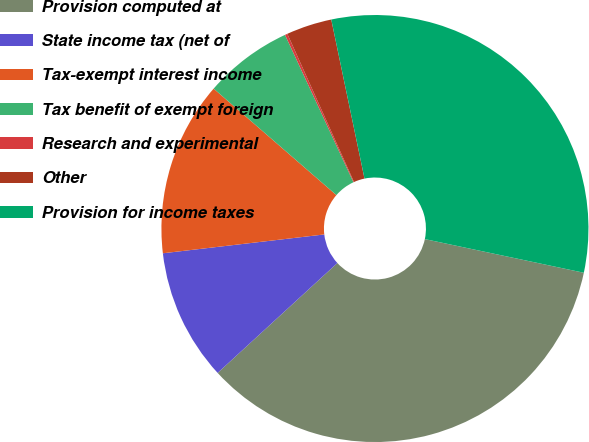<chart> <loc_0><loc_0><loc_500><loc_500><pie_chart><fcel>Provision computed at<fcel>State income tax (net of<fcel>Tax-exempt interest income<fcel>Tax benefit of exempt foreign<fcel>Research and experimental<fcel>Other<fcel>Provision for income taxes<nl><fcel>34.86%<fcel>9.97%<fcel>13.22%<fcel>6.71%<fcel>0.19%<fcel>3.45%<fcel>31.6%<nl></chart> 